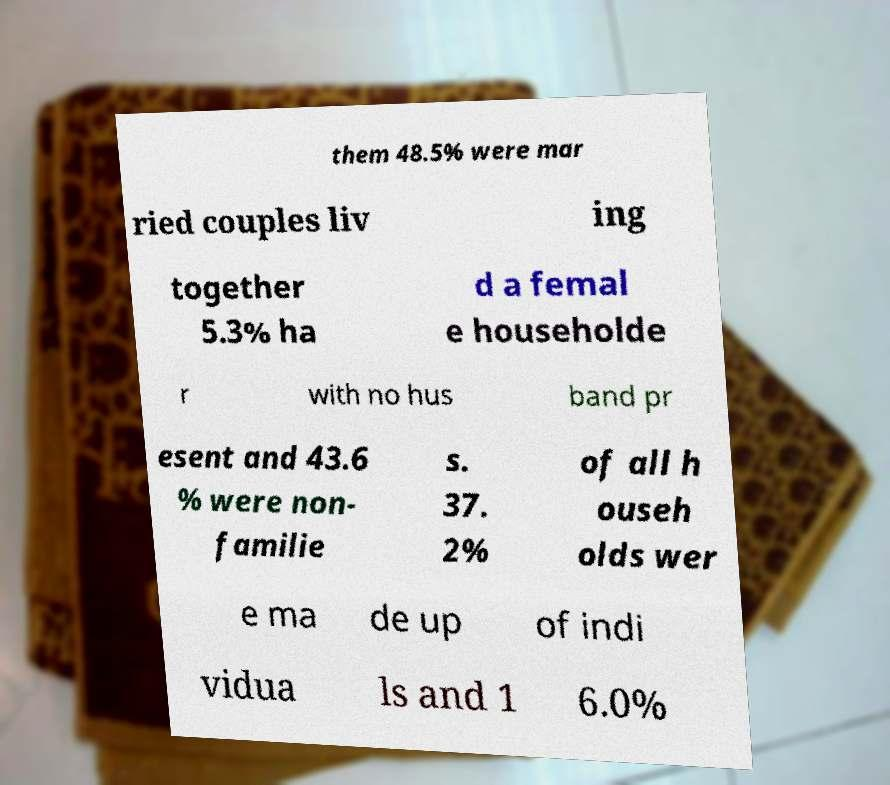Can you accurately transcribe the text from the provided image for me? them 48.5% were mar ried couples liv ing together 5.3% ha d a femal e householde r with no hus band pr esent and 43.6 % were non- familie s. 37. 2% of all h ouseh olds wer e ma de up of indi vidua ls and 1 6.0% 